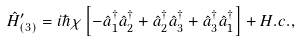<formula> <loc_0><loc_0><loc_500><loc_500>\hat { H } ^ { \prime } _ { ( 3 ) } = i \hbar { \chi } \left [ - \hat { a } _ { 1 } ^ { \dag } \hat { a } _ { 2 } ^ { \dag } + \hat { a } _ { 2 } ^ { \dag } \hat { a } _ { 3 } ^ { \dag } + \hat { a } _ { 3 } ^ { \dag } \hat { a } _ { 1 } ^ { \dag } \right ] + H . c . ,</formula> 